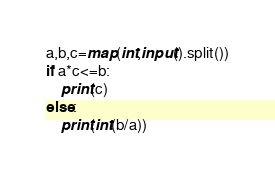<code> <loc_0><loc_0><loc_500><loc_500><_Python_>a,b,c=map(int,input().split())
if a*c<=b:
    print(c)
else:
    print(int(b/a))
</code> 